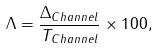Convert formula to latex. <formula><loc_0><loc_0><loc_500><loc_500>\Lambda = \frac { \Delta _ { C h a n n e l } } { T _ { C h a n n e l } } \times 1 0 0 ,</formula> 